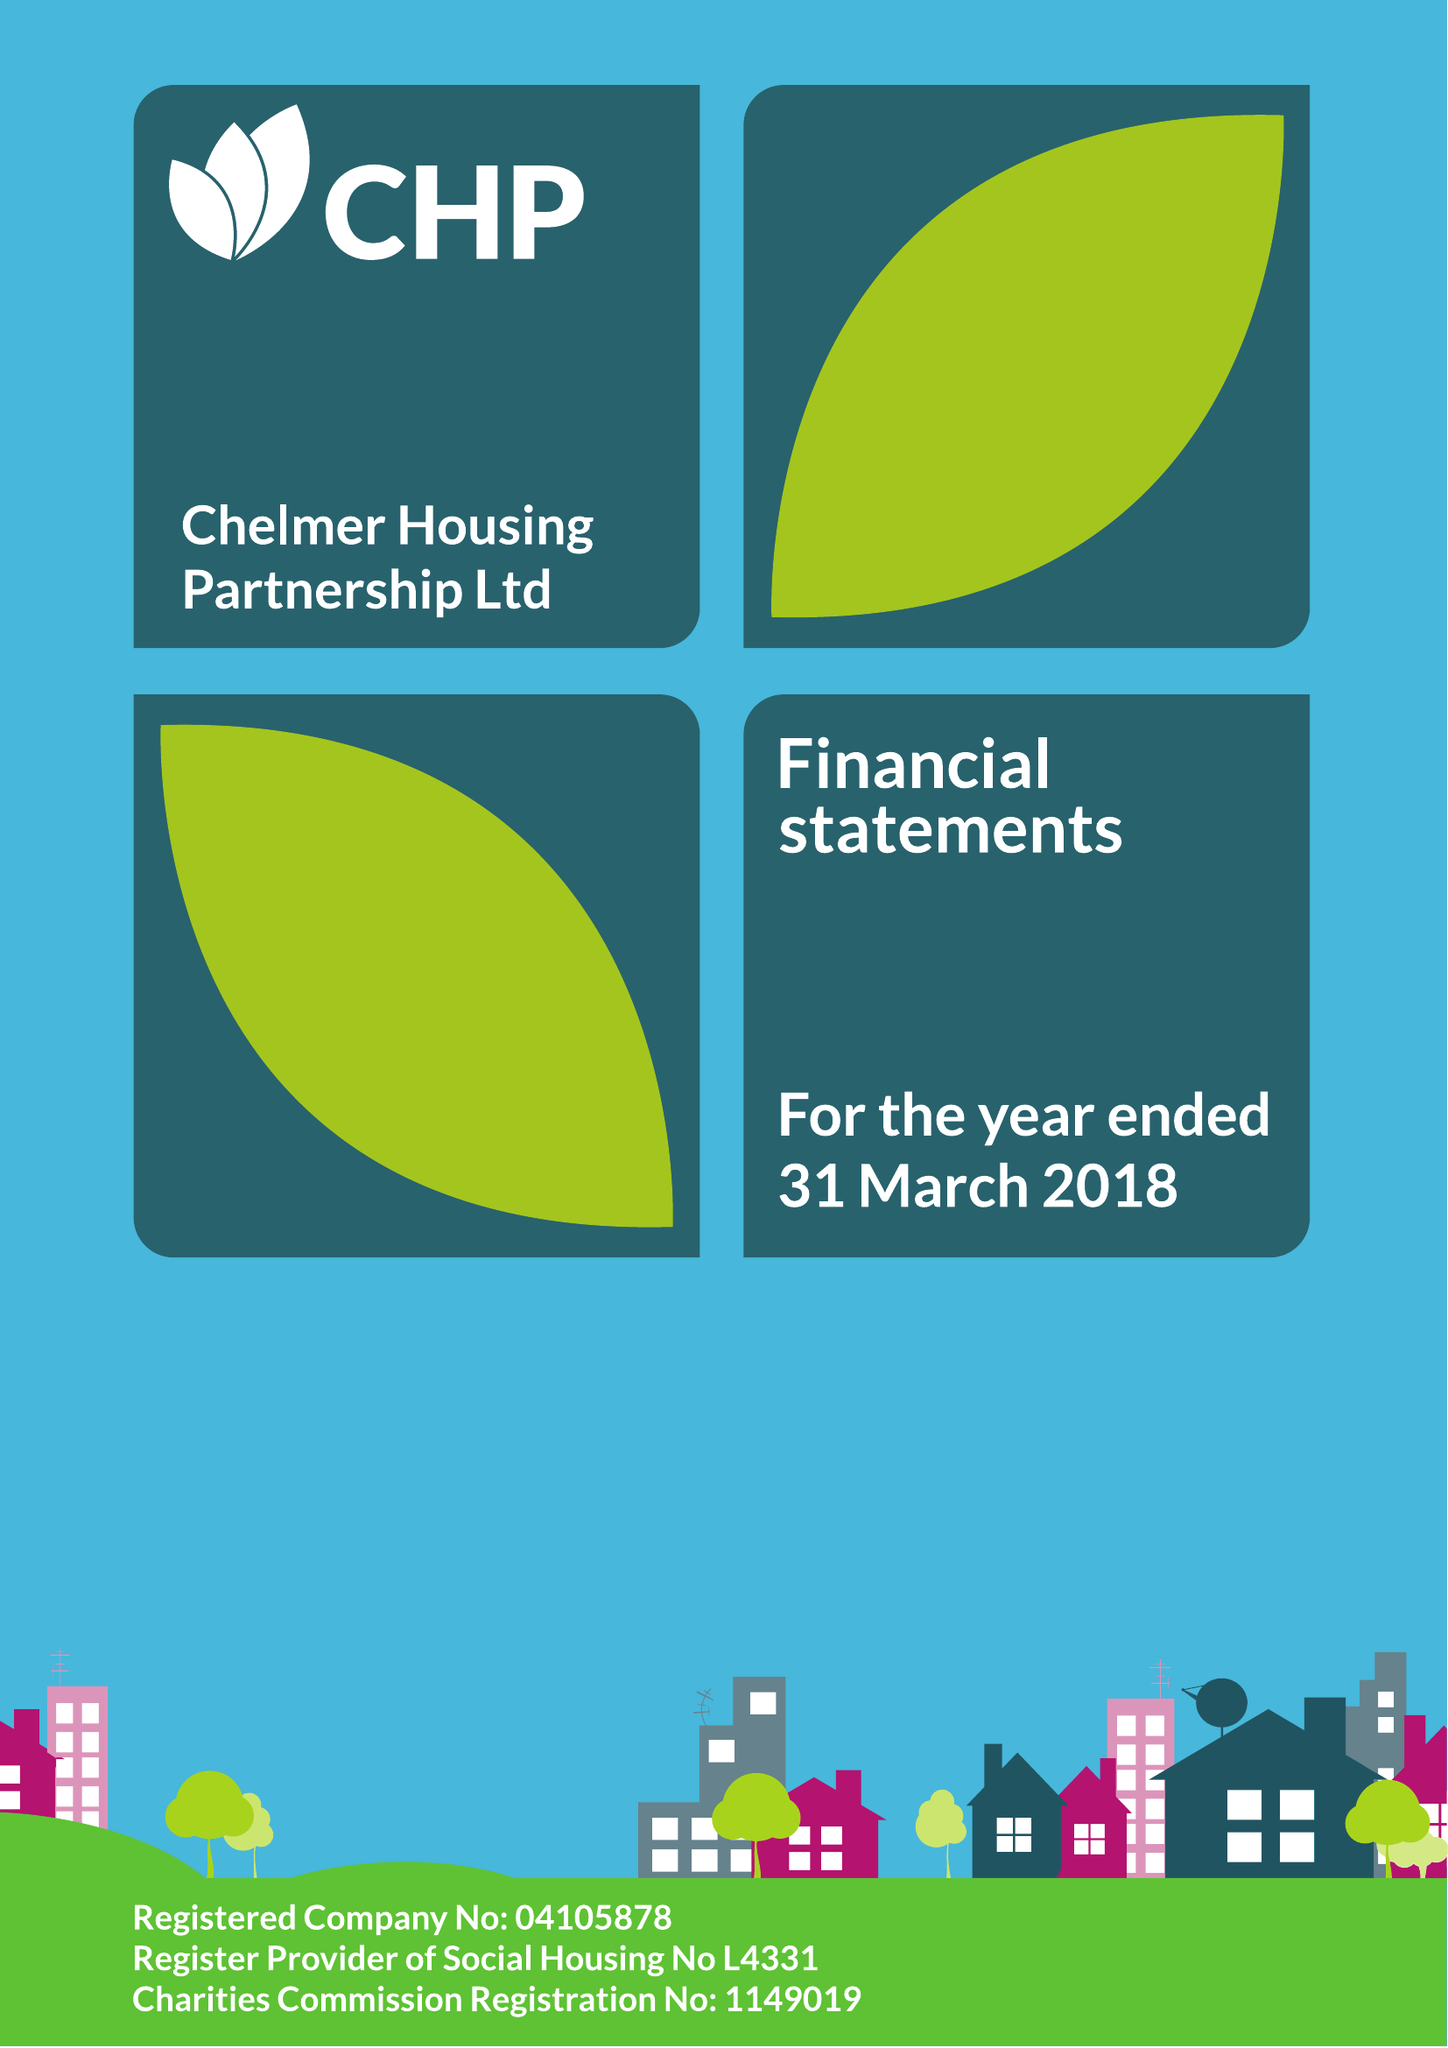What is the value for the report_date?
Answer the question using a single word or phrase. 2018-03-31 